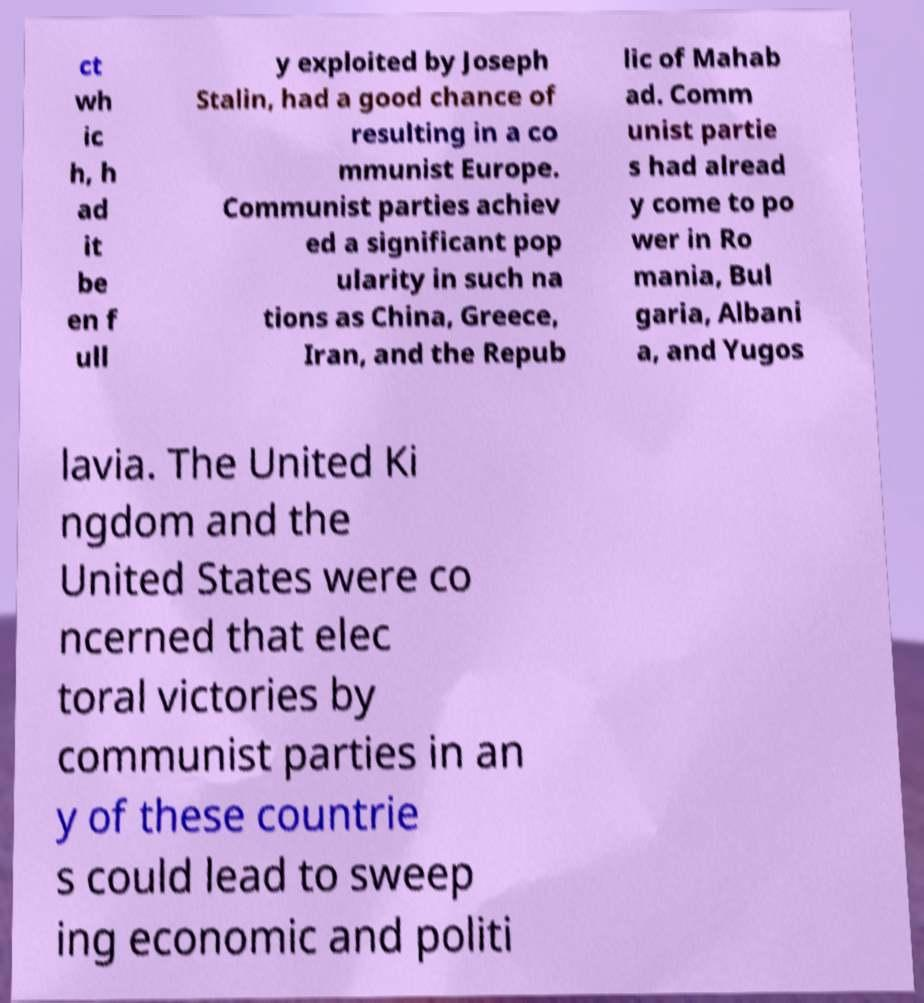There's text embedded in this image that I need extracted. Can you transcribe it verbatim? ct wh ic h, h ad it be en f ull y exploited by Joseph Stalin, had a good chance of resulting in a co mmunist Europe. Communist parties achiev ed a significant pop ularity in such na tions as China, Greece, Iran, and the Repub lic of Mahab ad. Comm unist partie s had alread y come to po wer in Ro mania, Bul garia, Albani a, and Yugos lavia. The United Ki ngdom and the United States were co ncerned that elec toral victories by communist parties in an y of these countrie s could lead to sweep ing economic and politi 